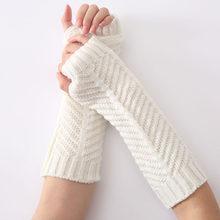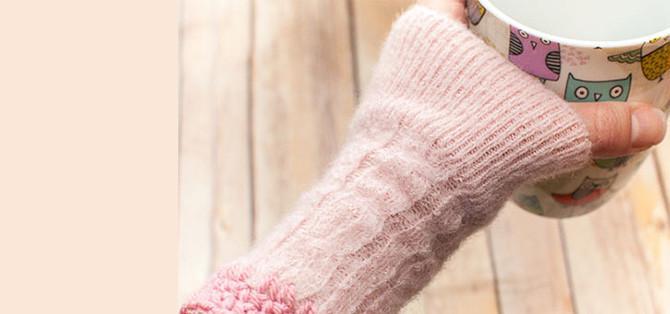The first image is the image on the left, the second image is the image on the right. Analyze the images presented: Is the assertion "At least one pair of hand warmers is dark red." valid? Answer yes or no. No. The first image is the image on the left, the second image is the image on the right. For the images displayed, is the sentence "The left and right image contains the same of fingerless gloves." factually correct? Answer yes or no. No. 